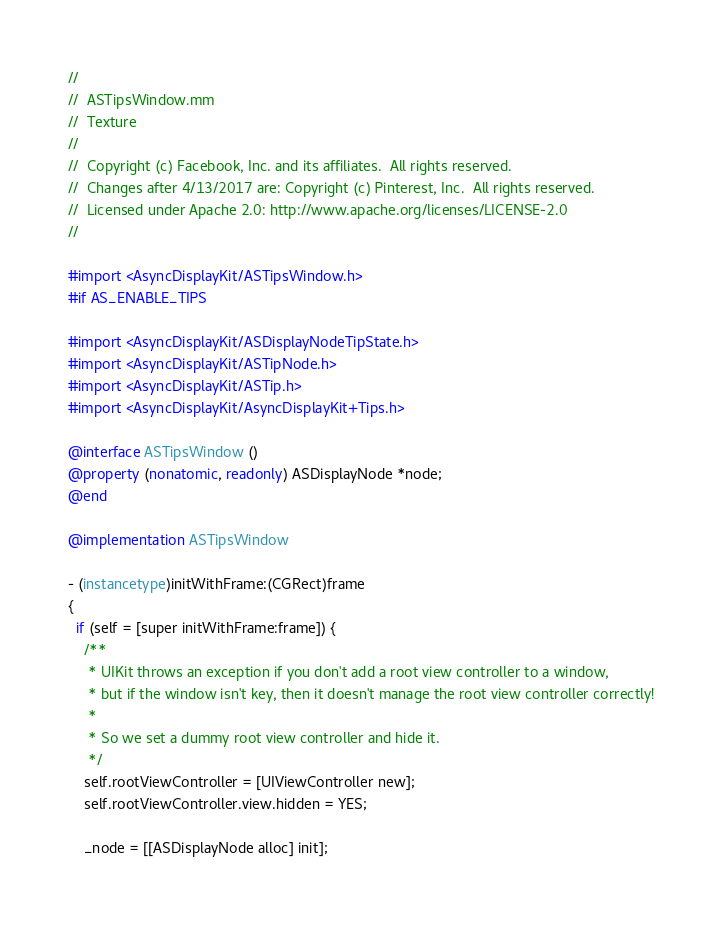<code> <loc_0><loc_0><loc_500><loc_500><_ObjectiveC_>//
//  ASTipsWindow.mm
//  Texture
//
//  Copyright (c) Facebook, Inc. and its affiliates.  All rights reserved.
//  Changes after 4/13/2017 are: Copyright (c) Pinterest, Inc.  All rights reserved.
//  Licensed under Apache 2.0: http://www.apache.org/licenses/LICENSE-2.0
//

#import <AsyncDisplayKit/ASTipsWindow.h>
#if AS_ENABLE_TIPS

#import <AsyncDisplayKit/ASDisplayNodeTipState.h>
#import <AsyncDisplayKit/ASTipNode.h>
#import <AsyncDisplayKit/ASTip.h>
#import <AsyncDisplayKit/AsyncDisplayKit+Tips.h>

@interface ASTipsWindow ()
@property (nonatomic, readonly) ASDisplayNode *node;
@end

@implementation ASTipsWindow

- (instancetype)initWithFrame:(CGRect)frame
{
  if (self = [super initWithFrame:frame]) {
    /**
     * UIKit throws an exception if you don't add a root view controller to a window,
     * but if the window isn't key, then it doesn't manage the root view controller correctly!
     *
     * So we set a dummy root view controller and hide it.
     */
    self.rootViewController = [UIViewController new];
    self.rootViewController.view.hidden = YES;

    _node = [[ASDisplayNode alloc] init];</code> 